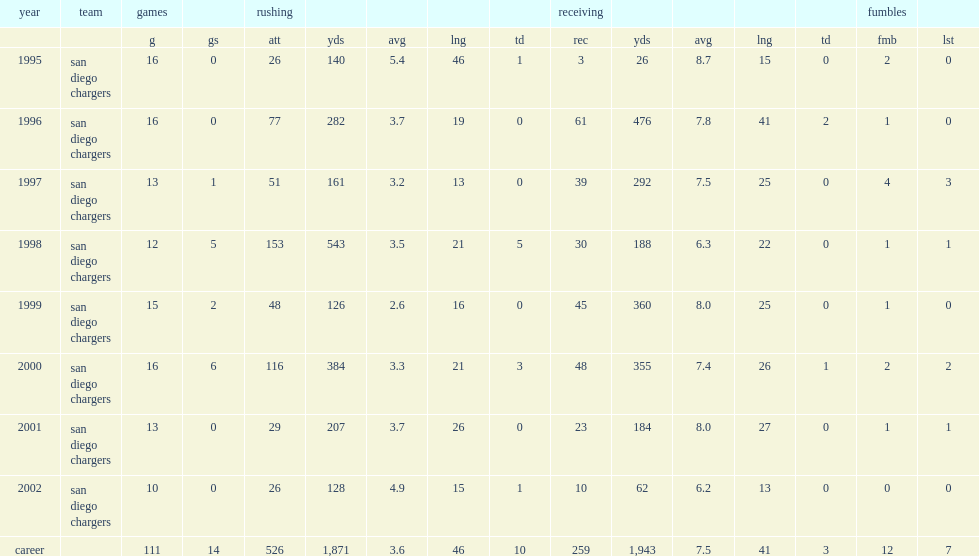I'm looking to parse the entire table for insights. Could you assist me with that? {'header': ['year', 'team', 'games', '', 'rushing', '', '', '', '', 'receiving', '', '', '', '', 'fumbles', ''], 'rows': [['', '', 'g', 'gs', 'att', 'yds', 'avg', 'lng', 'td', 'rec', 'yds', 'avg', 'lng', 'td', 'fmb', 'lst'], ['1995', 'san diego chargers', '16', '0', '26', '140', '5.4', '46', '1', '3', '26', '8.7', '15', '0', '2', '0'], ['1996', 'san diego chargers', '16', '0', '77', '282', '3.7', '19', '0', '61', '476', '7.8', '41', '2', '1', '0'], ['1997', 'san diego chargers', '13', '1', '51', '161', '3.2', '13', '0', '39', '292', '7.5', '25', '0', '4', '3'], ['1998', 'san diego chargers', '12', '5', '153', '543', '3.5', '21', '5', '30', '188', '6.3', '22', '0', '1', '1'], ['1999', 'san diego chargers', '15', '2', '48', '126', '2.6', '16', '0', '45', '360', '8.0', '25', '0', '1', '0'], ['2000', 'san diego chargers', '16', '6', '116', '384', '3.3', '21', '3', '48', '355', '7.4', '26', '1', '2', '2'], ['2001', 'san diego chargers', '13', '0', '29', '207', '3.7', '26', '0', '23', '184', '8.0', '27', '0', '1', '1'], ['2002', 'san diego chargers', '10', '0', '26', '128', '4.9', '15', '1', '10', '62', '6.2', '13', '0', '0', '0'], ['career', '', '111', '14', '526', '1,871', '3.6', '46', '10', '259', '1,943', '7.5', '41', '3', '12', '7']]} How many yards did fletcher rush with in his career? 1871.0. How many receptions did fletcher rush with in his career? 259.0. 